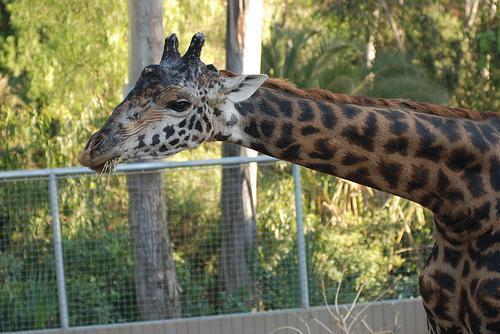How many giraffes are there?
Give a very brief answer. 1. 